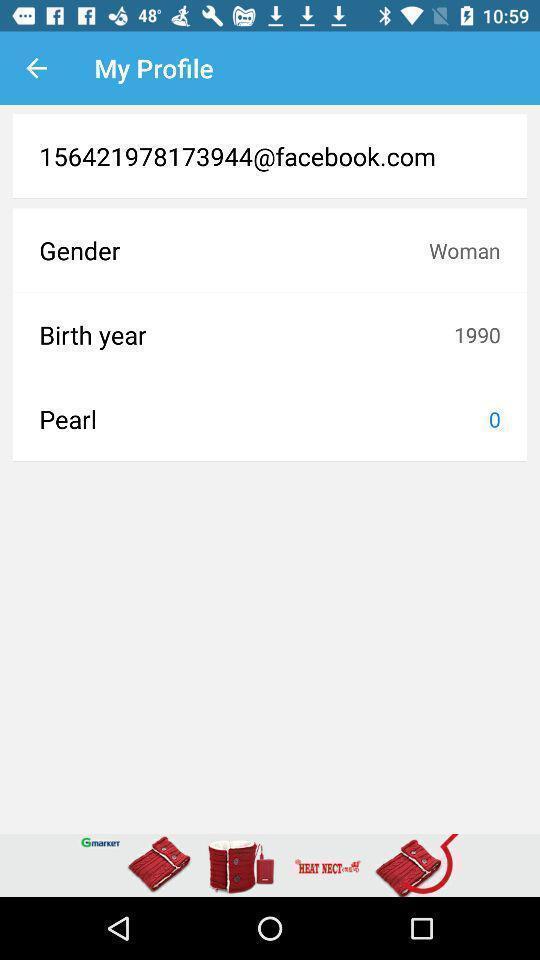Describe the key features of this screenshot. Profile page of an app. 